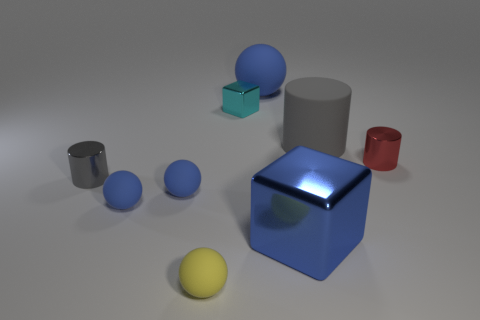What number of small objects are red metallic objects or blue shiny cubes? In the image, there is one small object that is either a red metallic object or a blue shiny cube. Specifically, it is the red metallic cylinder. 